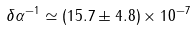<formula> <loc_0><loc_0><loc_500><loc_500>\delta \alpha ^ { - 1 } \simeq ( 1 5 . 7 \pm 4 . 8 ) \times 1 0 ^ { - 7 }</formula> 